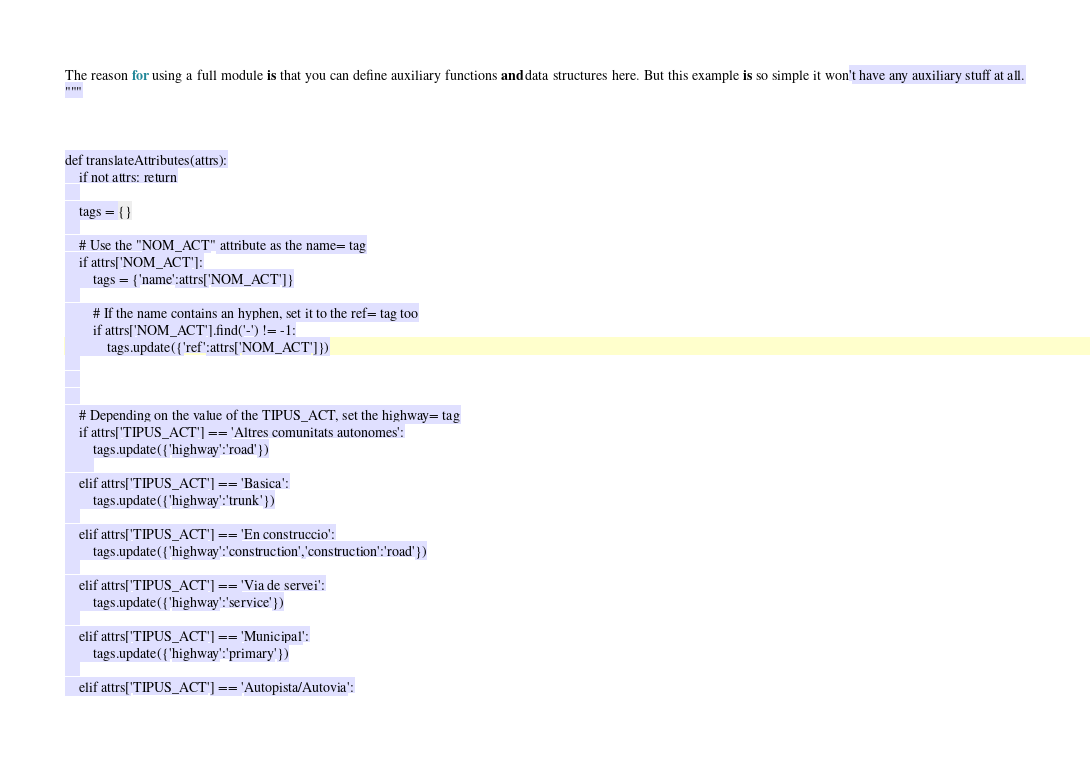Convert code to text. <code><loc_0><loc_0><loc_500><loc_500><_Python_>
The reason for using a full module is that you can define auxiliary functions and data structures here. But this example is so simple it won't have any auxiliary stuff at all.
"""



def translateAttributes(attrs):
	if not attrs: return
	
	tags = {}
	
	# Use the "NOM_ACT" attribute as the name= tag
	if attrs['NOM_ACT']:
		tags = {'name':attrs['NOM_ACT']}
	
		# If the name contains an hyphen, set it to the ref= tag too
		if attrs['NOM_ACT'].find('-') != -1:
			tags.update({'ref':attrs['NOM_ACT']})
	
	
	
	# Depending on the value of the TIPUS_ACT, set the highway= tag
	if attrs['TIPUS_ACT'] == 'Altres comunitats autonomes':
		tags.update({'highway':'road'})
		
	elif attrs['TIPUS_ACT'] == 'Basica':
		tags.update({'highway':'trunk'})
	
	elif attrs['TIPUS_ACT'] == 'En construccio':
		tags.update({'highway':'construction','construction':'road'})
	
	elif attrs['TIPUS_ACT'] == 'Via de servei':
		tags.update({'highway':'service'})
	
	elif attrs['TIPUS_ACT'] == 'Municipal':
		tags.update({'highway':'primary'})
	
	elif attrs['TIPUS_ACT'] == 'Autopista/Autovia':</code> 